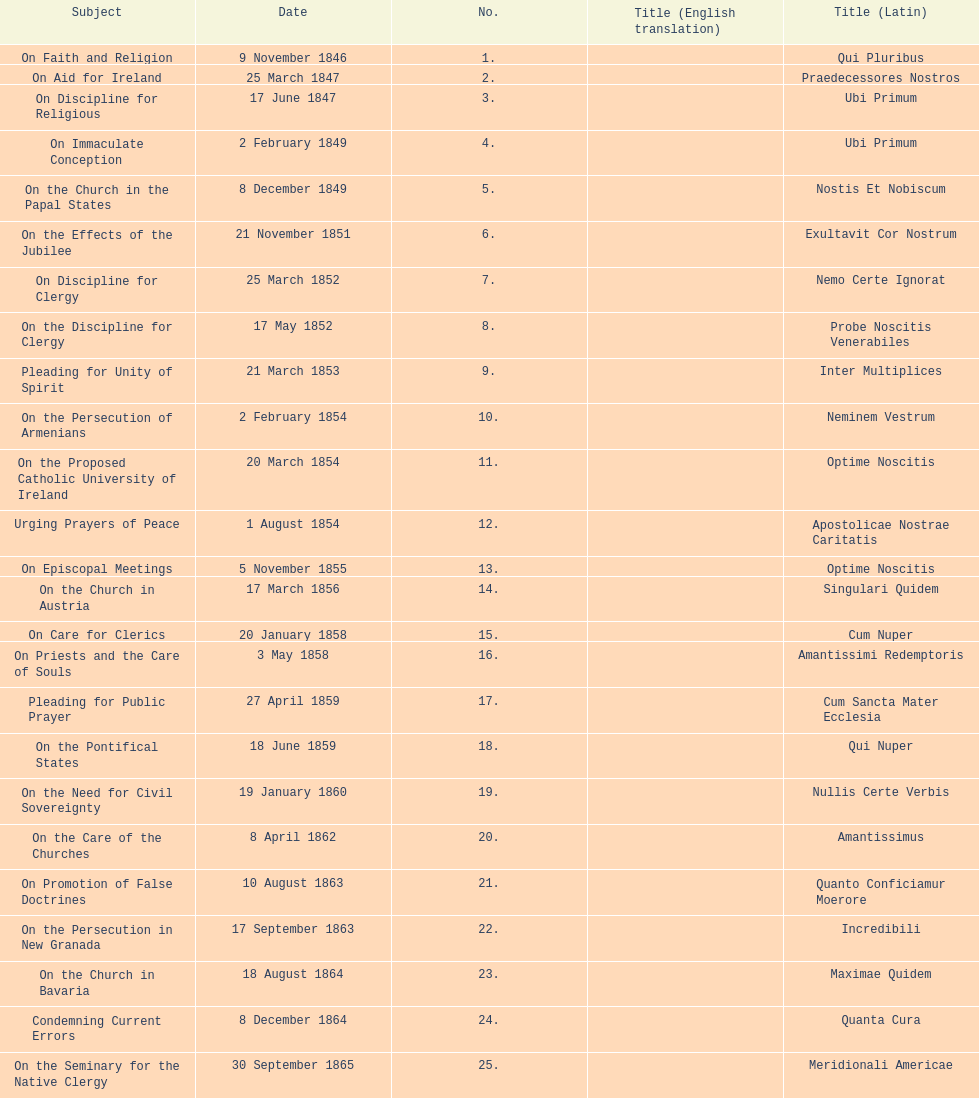How many encyclicals were issued between august 15, 1854 and october 26, 1867? 13. 